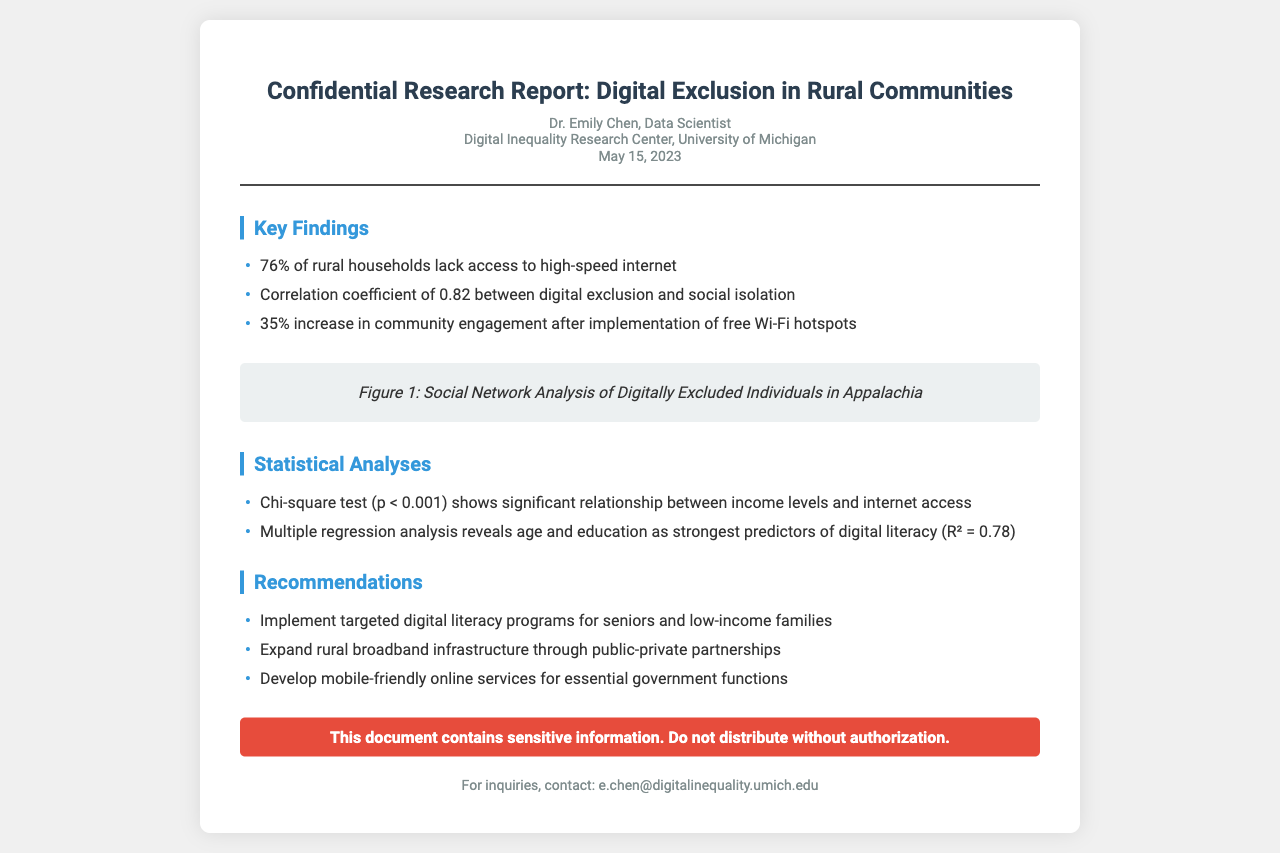what is the percentage of rural households lacking high-speed internet? The document states that 76% of rural households lack access to high-speed internet.
Answer: 76% who is the author of the report? The report was authored by Dr. Emily Chen, a Data Scientist.
Answer: Dr. Emily Chen what is the correlation coefficient between digital exclusion and social isolation? The document provides a correlation coefficient of 0.82 between digital exclusion and social isolation.
Answer: 0.82 how much did community engagement increase after implementing free Wi-Fi hotspots? The document notes a 35% increase in community engagement.
Answer: 35% what is the p-value from the Chi-square test regarding the relationship between income levels and internet access? The Chi-square test shows a p-value less than 0.001 indicating a significant relationship.
Answer: p < 0.001 which demographic factors are identified as predictors of digital literacy? The report states that age and education are the strongest predictors of digital literacy.
Answer: age and education what is Figure 1 about? Figure 1 illustrates the social network analysis of digitally excluded individuals in Appalachia.
Answer: Social Network Analysis of Digitally Excluded Individuals in Appalachia what type of programs does the report recommend? The report recommends implementing targeted digital literacy programs.
Answer: targeted digital literacy programs when was the research report published? The report is dated May 15, 2023.
Answer: May 15, 2023 